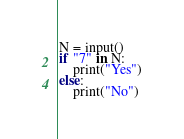<code> <loc_0><loc_0><loc_500><loc_500><_Python_>N = input()
if "7" in N:
    print("Yes")
else:
    print("No")</code> 